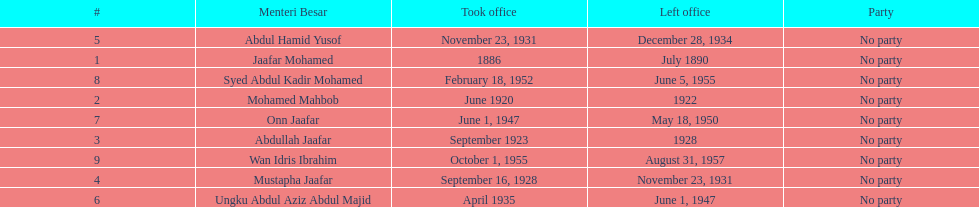Who took office after onn jaafar? Syed Abdul Kadir Mohamed. 